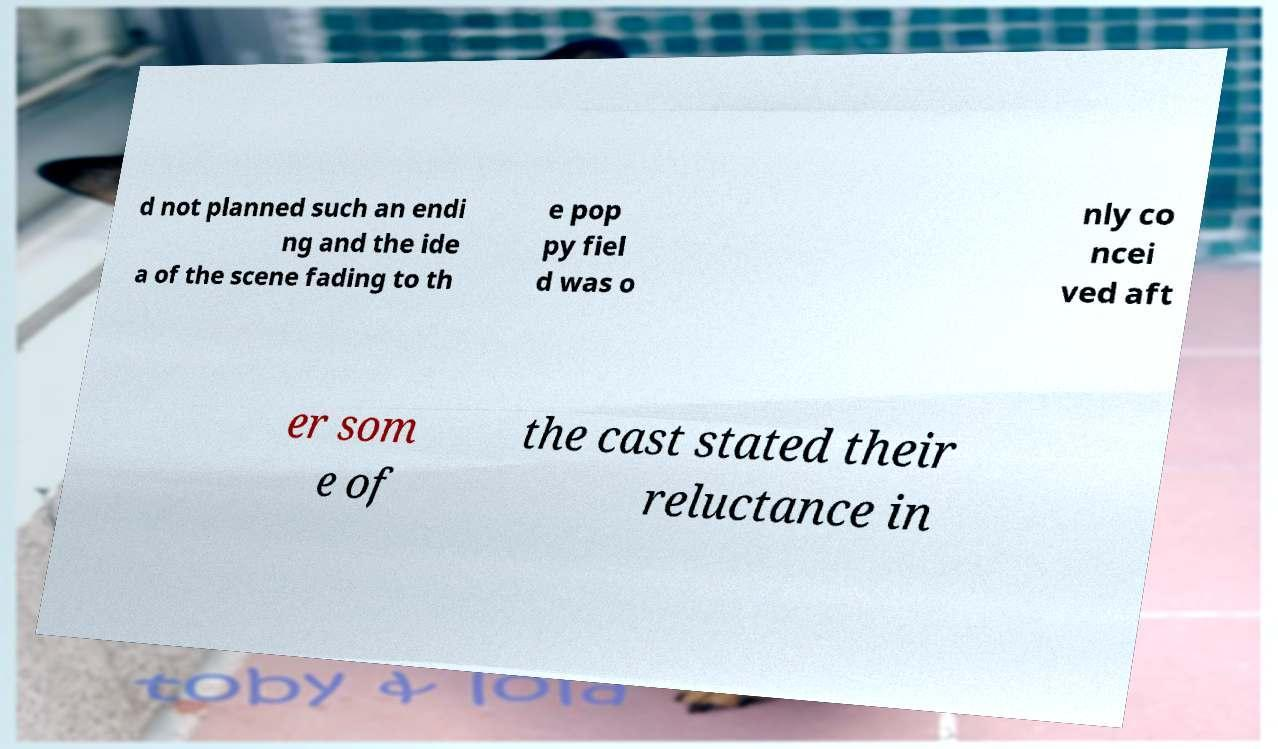Please read and relay the text visible in this image. What does it say? d not planned such an endi ng and the ide a of the scene fading to th e pop py fiel d was o nly co ncei ved aft er som e of the cast stated their reluctance in 